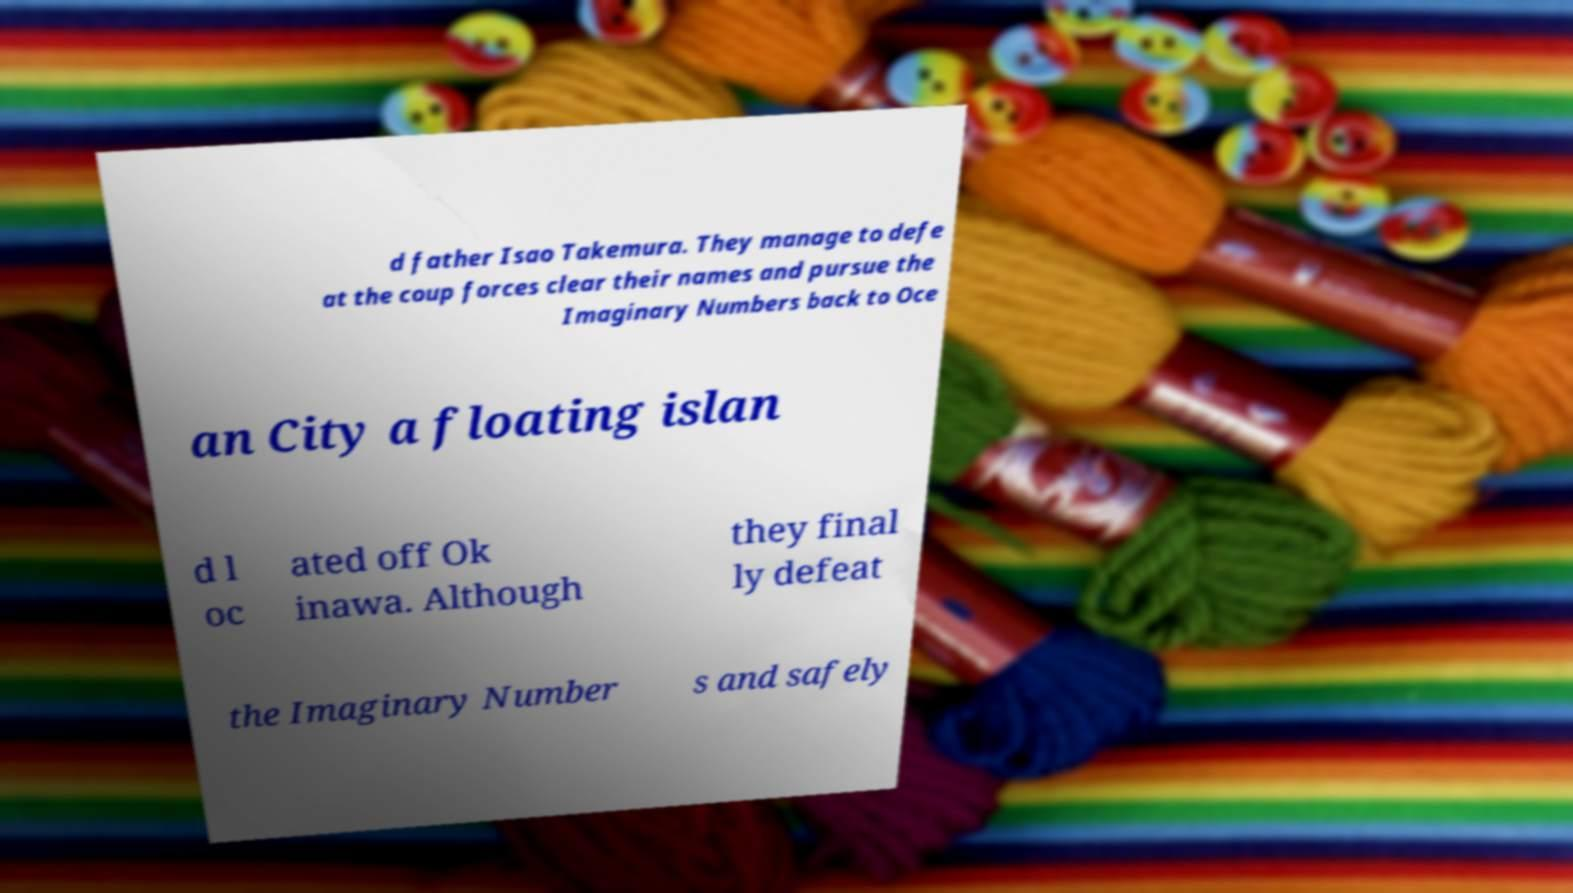I need the written content from this picture converted into text. Can you do that? d father Isao Takemura. They manage to defe at the coup forces clear their names and pursue the Imaginary Numbers back to Oce an City a floating islan d l oc ated off Ok inawa. Although they final ly defeat the Imaginary Number s and safely 